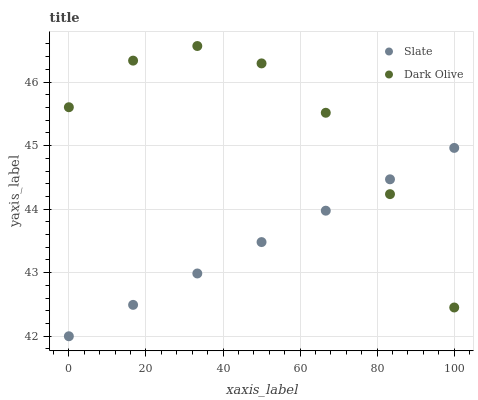Does Slate have the minimum area under the curve?
Answer yes or no. Yes. Does Dark Olive have the maximum area under the curve?
Answer yes or no. Yes. Does Dark Olive have the minimum area under the curve?
Answer yes or no. No. Is Slate the smoothest?
Answer yes or no. Yes. Is Dark Olive the roughest?
Answer yes or no. Yes. Is Dark Olive the smoothest?
Answer yes or no. No. Does Slate have the lowest value?
Answer yes or no. Yes. Does Dark Olive have the lowest value?
Answer yes or no. No. Does Dark Olive have the highest value?
Answer yes or no. Yes. Does Slate intersect Dark Olive?
Answer yes or no. Yes. Is Slate less than Dark Olive?
Answer yes or no. No. Is Slate greater than Dark Olive?
Answer yes or no. No. 